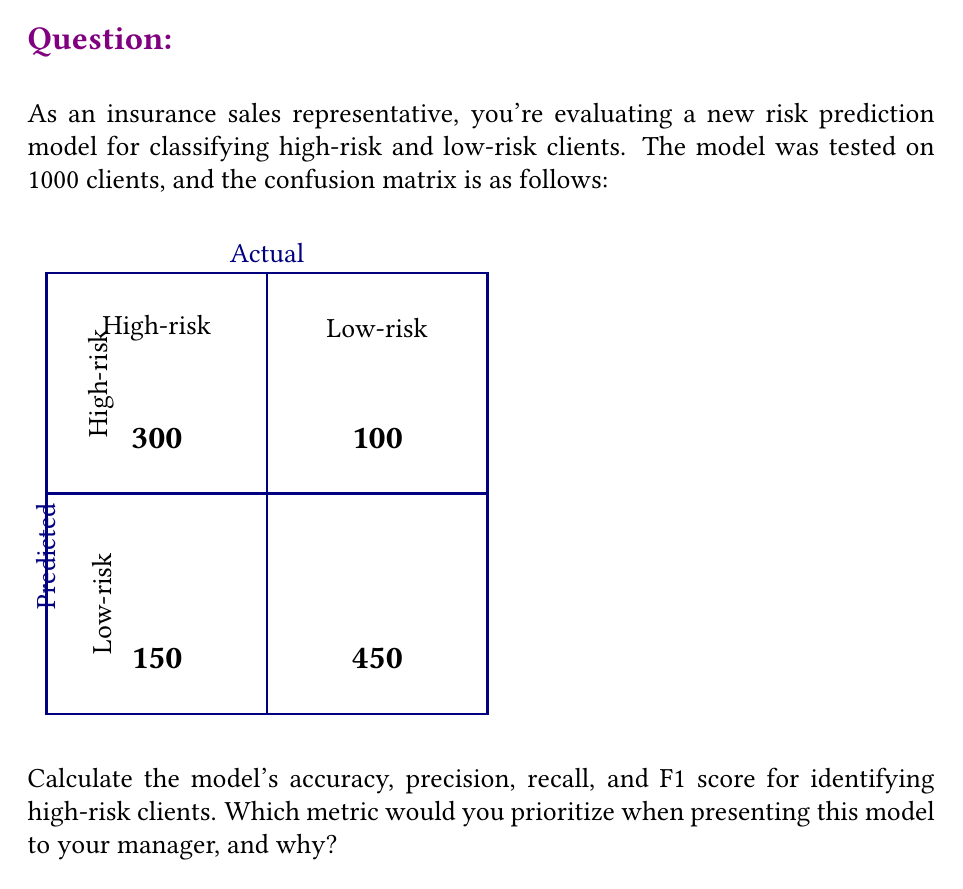Solve this math problem. Let's calculate each metric step-by-step:

1. Accuracy:
   Accuracy = (TP + TN) / (TP + FP + FN + TN)
   $$ \text{Accuracy} = \frac{300 + 450}{300 + 100 + 150 + 450} = \frac{750}{1000} = 0.75 = 75\% $$

2. Precision (for high-risk clients):
   Precision = TP / (TP + FP)
   $$ \text{Precision} = \frac{300}{300 + 100} = \frac{300}{400} = 0.75 = 75\% $$

3. Recall (for high-risk clients):
   Recall = TP / (TP + FN)
   $$ \text{Recall} = \frac{300}{300 + 150} = \frac{300}{450} = \frac{2}{3} \approx 0.6667 = 66.67\% $$

4. F1 Score:
   F1 Score = 2 * (Precision * Recall) / (Precision + Recall)
   $$ \text{F1 Score} = \frac{2 * (0.75 * 0.6667)}{0.75 + 0.6667} \approx 0.7059 = 70.59\% $$

As an insurance sales representative, you might prioritize the precision metric when presenting this model to your manager. Precision measures the accuracy of positive predictions, which in this case represents the proportion of clients correctly identified as high-risk among all those predicted as high-risk.

Rationale for prioritizing precision:
1. Minimizes false positives: High precision means fewer low-risk clients are misclassified as high-risk, reducing the risk of unnecessarily high premiums or denied coverage.
2. Builds trust: Accurate high-risk predictions demonstrate the model's reliability, which is crucial in the insurance industry.
3. Cost-effective: Focusing resources on truly high-risk clients improves the company's risk management and profitability.

However, it's important to note that the choice of metric depends on the specific goals and risk tolerance of the insurance company. In some cases, recall might be prioritized to ensure that as many high-risk clients as possible are identified, even at the cost of some false positives.
Answer: Accuracy: 75%, Precision: 75%, Recall: 66.67%, F1 Score: 70.59%. Prioritize precision for minimizing false positives and demonstrating model reliability. 